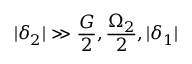<formula> <loc_0><loc_0><loc_500><loc_500>| \delta _ { 2 } | \gg \frac { G } { 2 } , \frac { \Omega _ { 2 } } { 2 } , | \delta _ { 1 } |</formula> 